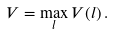<formula> <loc_0><loc_0><loc_500><loc_500>V = \max _ { l } V ( l ) \, .</formula> 